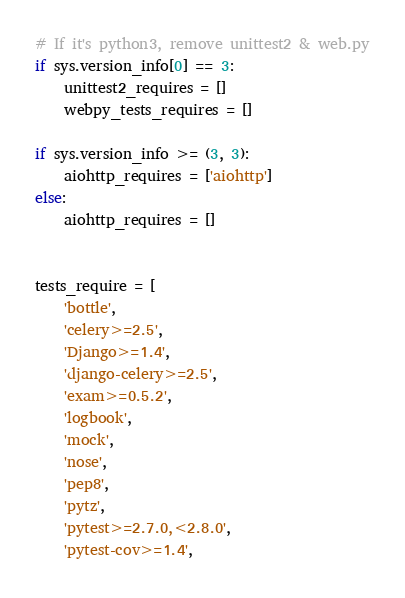Convert code to text. <code><loc_0><loc_0><loc_500><loc_500><_Python_>
# If it's python3, remove unittest2 & web.py
if sys.version_info[0] == 3:
    unittest2_requires = []
    webpy_tests_requires = []

if sys.version_info >= (3, 3):
    aiohttp_requires = ['aiohttp']
else:
    aiohttp_requires = []


tests_require = [
    'bottle',
    'celery>=2.5',
    'Django>=1.4',
    'django-celery>=2.5',
    'exam>=0.5.2',
    'logbook',
    'mock',
    'nose',
    'pep8',
    'pytz',
    'pytest>=2.7.0,<2.8.0',
    'pytest-cov>=1.4',</code> 